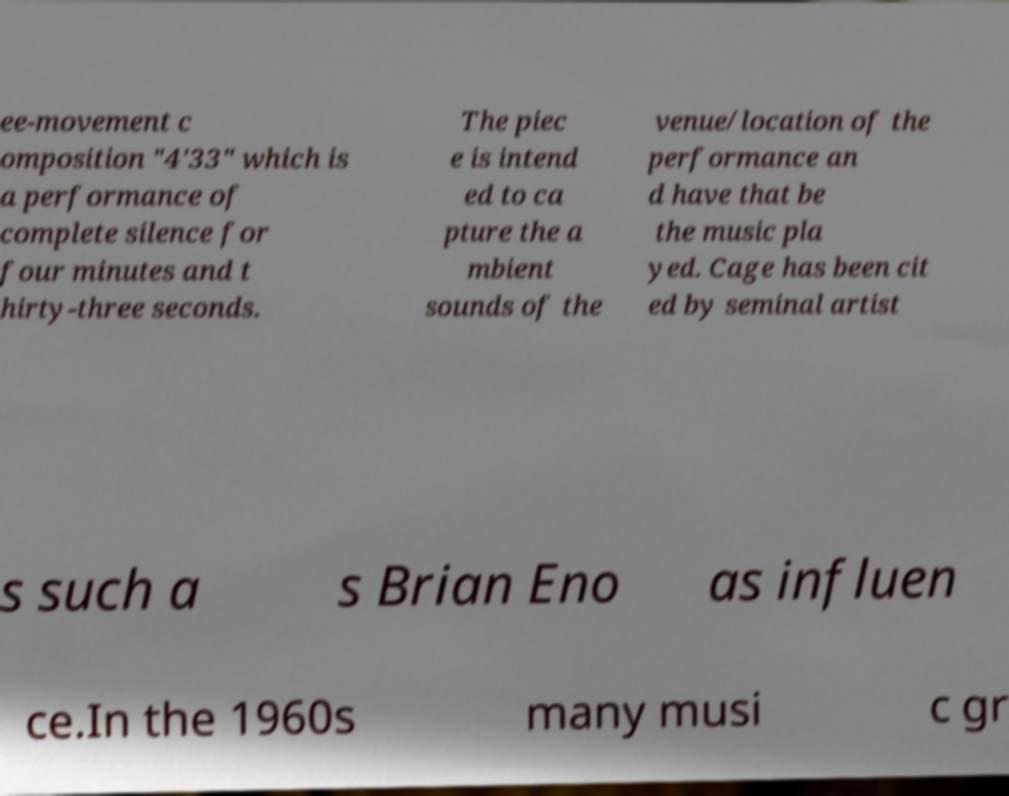Could you extract and type out the text from this image? ee-movement c omposition "4'33" which is a performance of complete silence for four minutes and t hirty-three seconds. The piec e is intend ed to ca pture the a mbient sounds of the venue/location of the performance an d have that be the music pla yed. Cage has been cit ed by seminal artist s such a s Brian Eno as influen ce.In the 1960s many musi c gr 